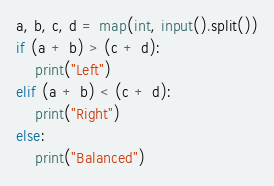Convert code to text. <code><loc_0><loc_0><loc_500><loc_500><_Python_>a, b, c, d = map(int, input().split())
if (a + b) > (c + d):
    print("Left")
elif (a + b) < (c + d):
    print("Right")
else:
    print("Balanced")</code> 